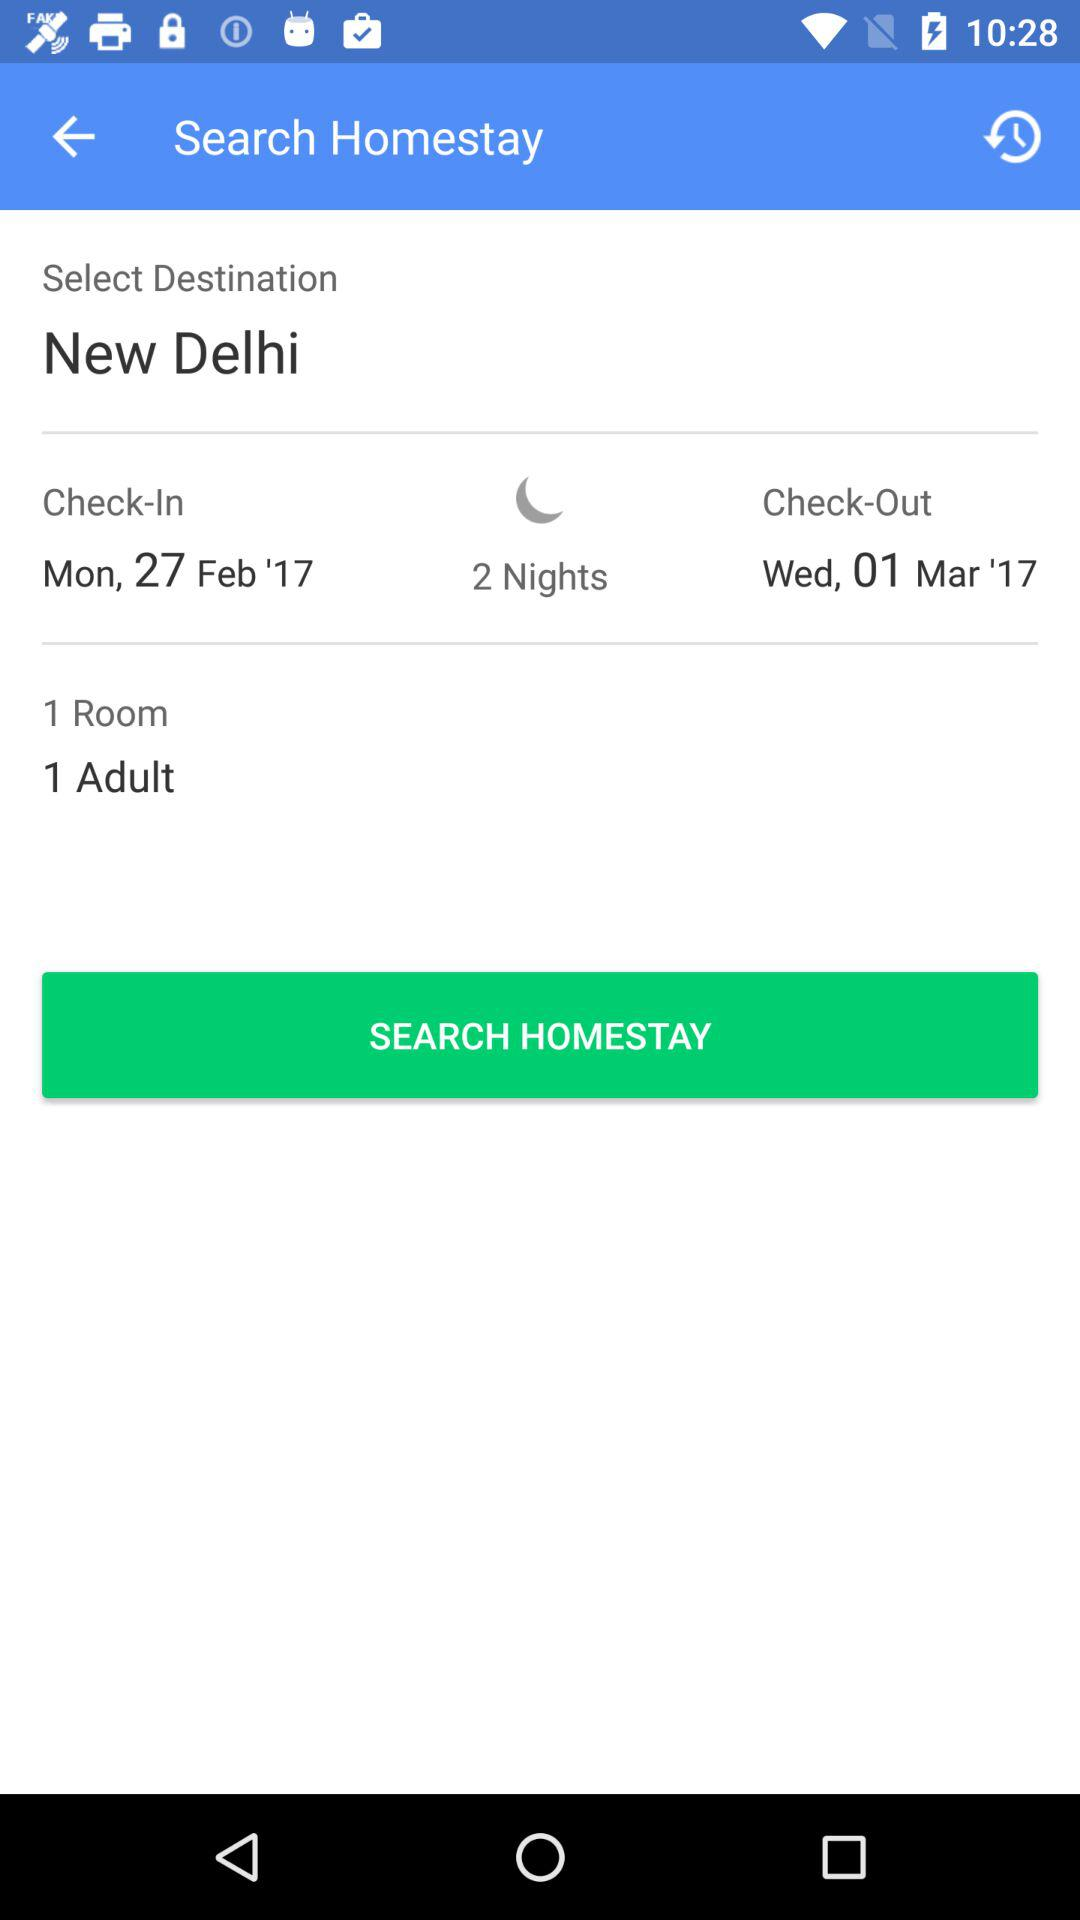What is the selected destination? The selected destination is New Delhi. 